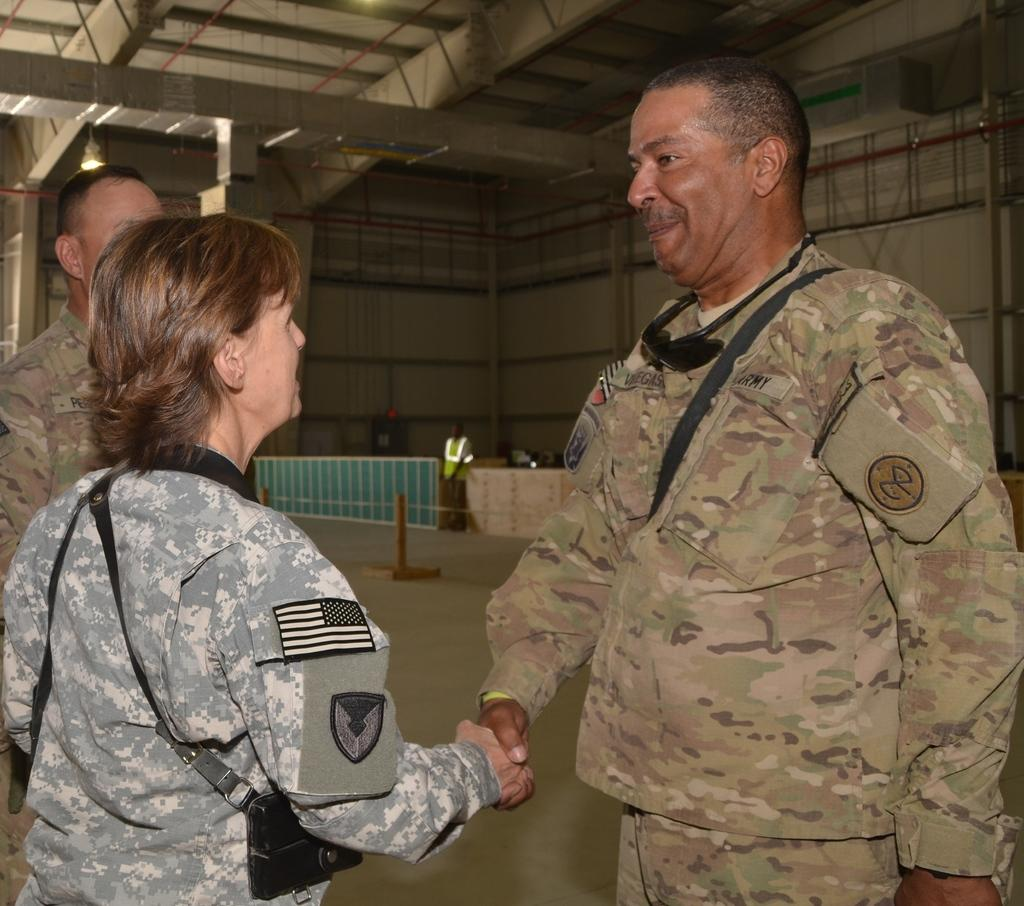How many military officers are present in the image? There are three military officers in the image, two male officers and one lady officer. What are the officers doing in the image? The officers are shaking hands in the image. What can be seen in the background of the image? There is a metal frame and a green color fencing grill in the background of the image. What type of loss is the lady officer experiencing in the image? There is no indication of any loss in the image; the officers are shaking hands, which suggests a positive interaction. 